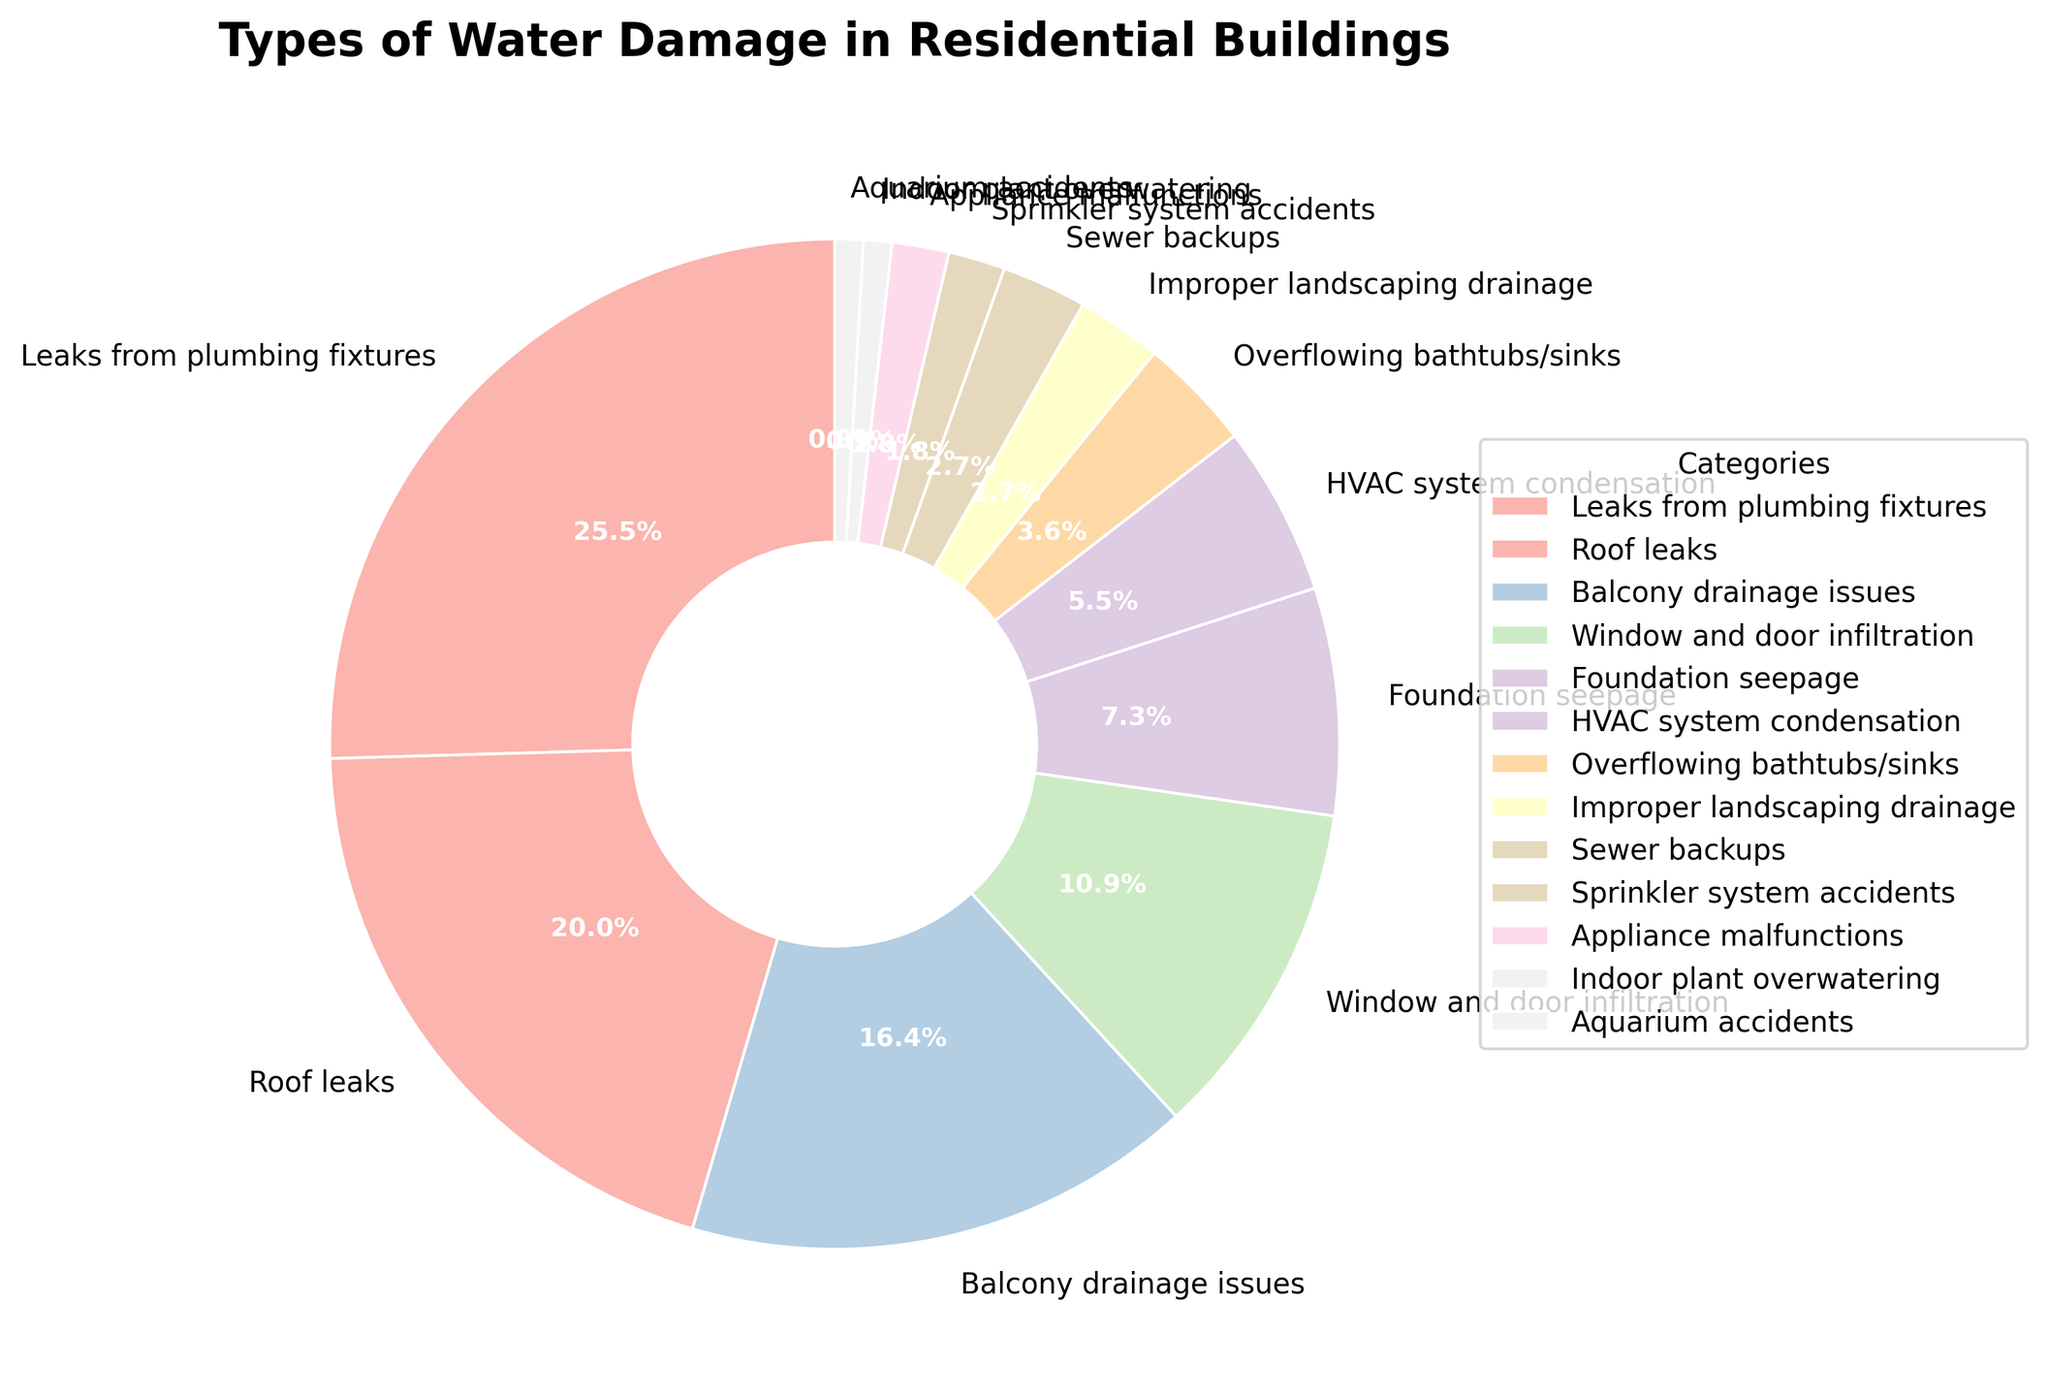Which category of water damage is reported the most frequently? This is an easy-to-answer question by looking at the largest slice of the pie chart. The largest slice is labeled as "Leaks from plumbing fixtures" with 28%.
Answer: Leaks from plumbing fixtures What is the combined percentage of roof leaks and balcony drainage issues? To find the combined percentage, add the individual percentages of roof leaks (22%) and balcony drainage issues (18%). The sum is 22% + 18% = 40%.
Answer: 40% Which is more common, window and door infiltration or HVAC system condensation? To determine this, compare their percentages. Window and door infiltration has 12%, while HVAC system condensation has 6%. Since 12% is greater than 6%, window and door infiltration is more common.
Answer: Window and door infiltration What percentage of water damage issues are caused by appliance malfunctions? Look at the pie chart to find the slice labeled "Appliance malfunctions." It shows a percentage of 2%.
Answer: 2% If we group all issues that have a percentage lower than overflowing bathtubs/sinks into a single category, what would be the combined percentage? Overflowing bathtubs/sinks is 4%. Categories with lower percentages are sewer backups (3%), improper landscaping drainage (3%), appliance malfunctions (2%), sprinkler system accidents (2%), and aquarium accidents and indoor plant overwatering (1% each). Add these percentages: 3% + 3% + 2% + 2% + 1% + 1% = 12%.
Answer: 12% What is the percentage difference between foundation seepage and improper landscaping drainage? Foundation seepage is 8%, and improper landscaping drainage is 3%. Subtract the smaller percentage from the larger one: 8% - 3% = 5%.
Answer: 5% How many categories account for less than 5% each? Identify the segments on the pie chart with less than 5%. They are sewer backups (3%), improper landscaping drainage (3%), appliance malfunctions (2%), sprinkler system accidents (2%), aquarium accidents (1%), and indoor plant overwatering (1%). There are 6 categories.
Answer: 6 Is indoor plant overwatering more or less common than aquarium accidents? Compare their percentages. Indoor plant overwatering and aquarium accidents both have a percentage of 1%. Since they are equal, neither is more common.
Answer: Equal What is the combined percentage of the three least common water damage categories? The three least common categories are indoor plant overwatering (1%), aquarium accidents (1%), and sprinkler system accidents (2%). Add these percentages: 1% + 1% + 2% = 4%.
Answer: 4% How does the frequency of roof leaks compare to balcony drainage issues? Roof leaks have a percentage of 22%, and balcony drainage issues have a percentage of 18%. Since 22% is greater than 18%, roof leaks are more frequent.
Answer: Roof leaks 